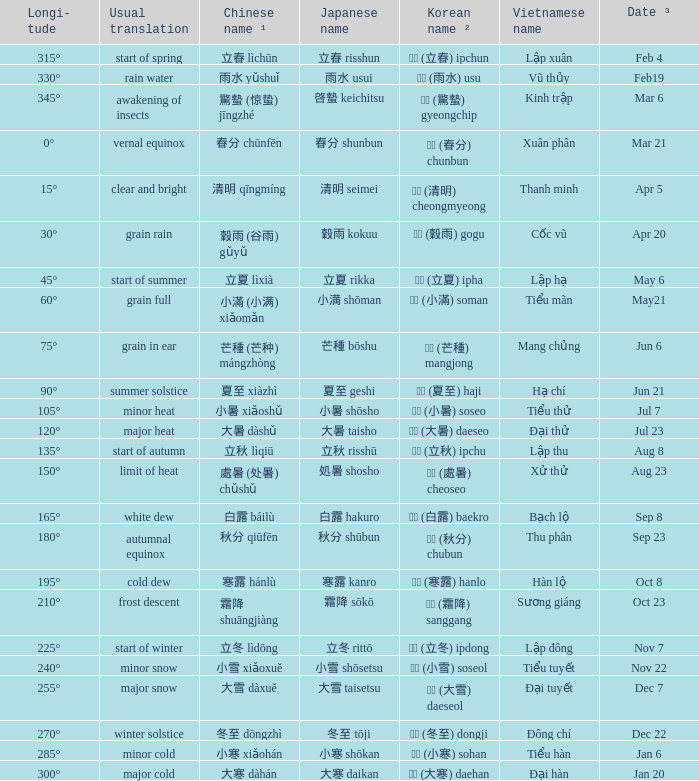WHICH Usual translation is on jun 21? Summer solstice. 